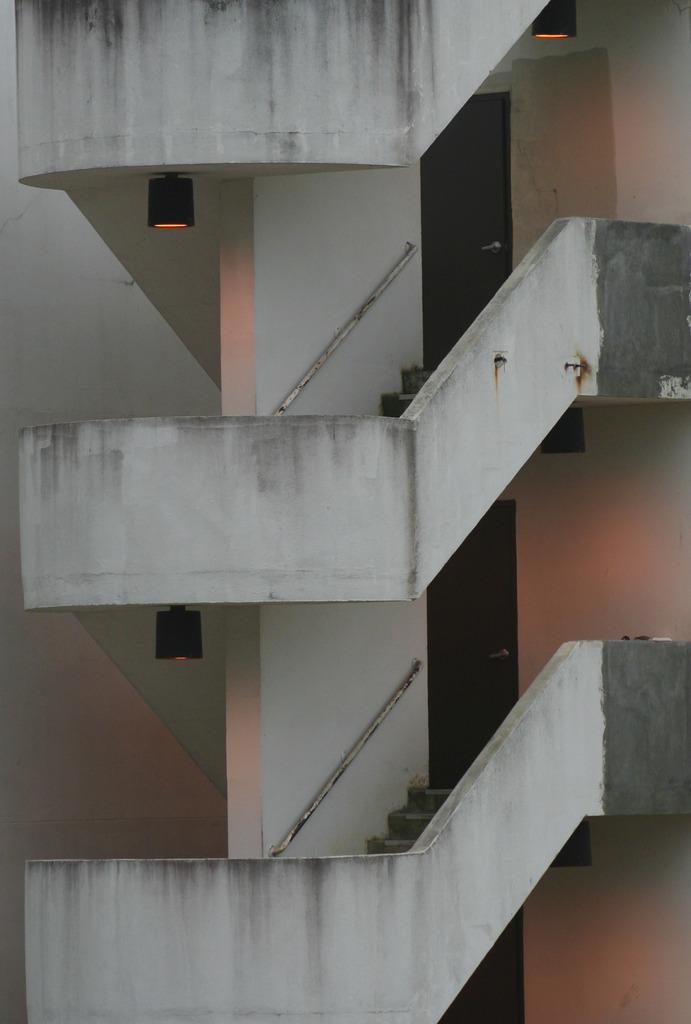What type of structure is present in the image? There is a staircase in the image. What is the staircase a part of? The staircase is part of a building. Are there any other architectural features visible in the image? Yes, there are doors visible in the image. How does the staircase help the person breathe better in the image? The image does not show any person or any indication of breathing issues, so it is not possible to determine how the staircase might affect someone's breathing. 